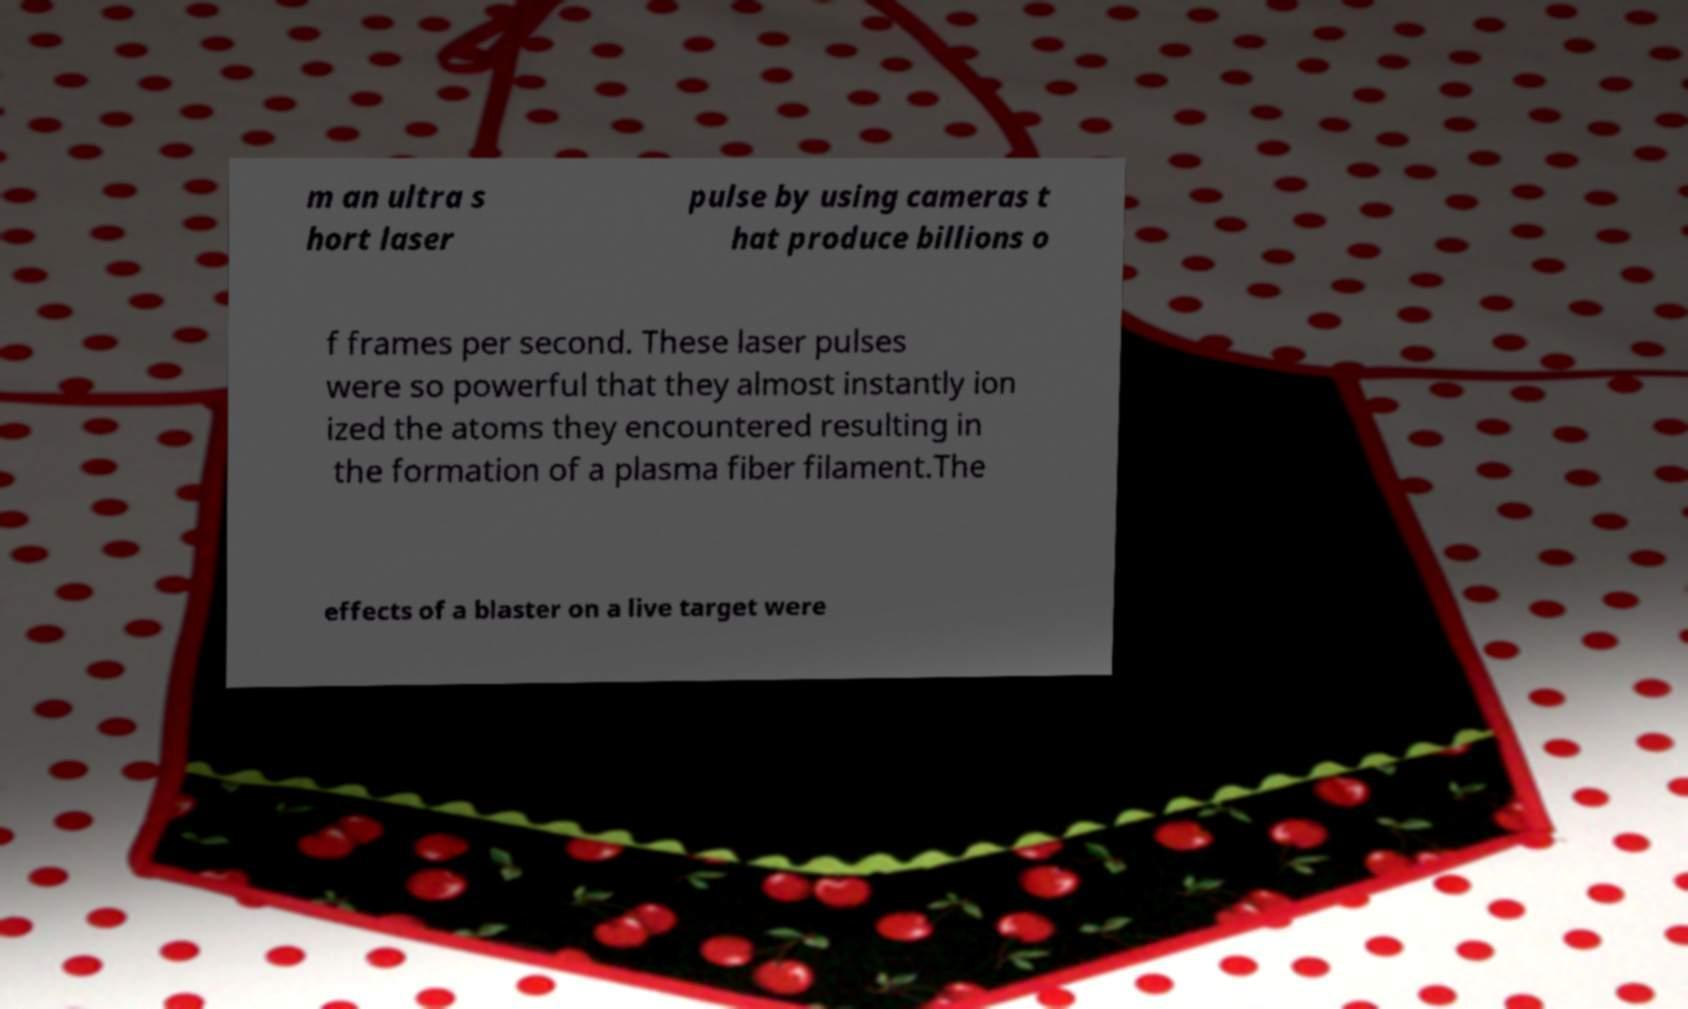Please read and relay the text visible in this image. What does it say? m an ultra s hort laser pulse by using cameras t hat produce billions o f frames per second. These laser pulses were so powerful that they almost instantly ion ized the atoms they encountered resulting in the formation of a plasma fiber filament.The effects of a blaster on a live target were 